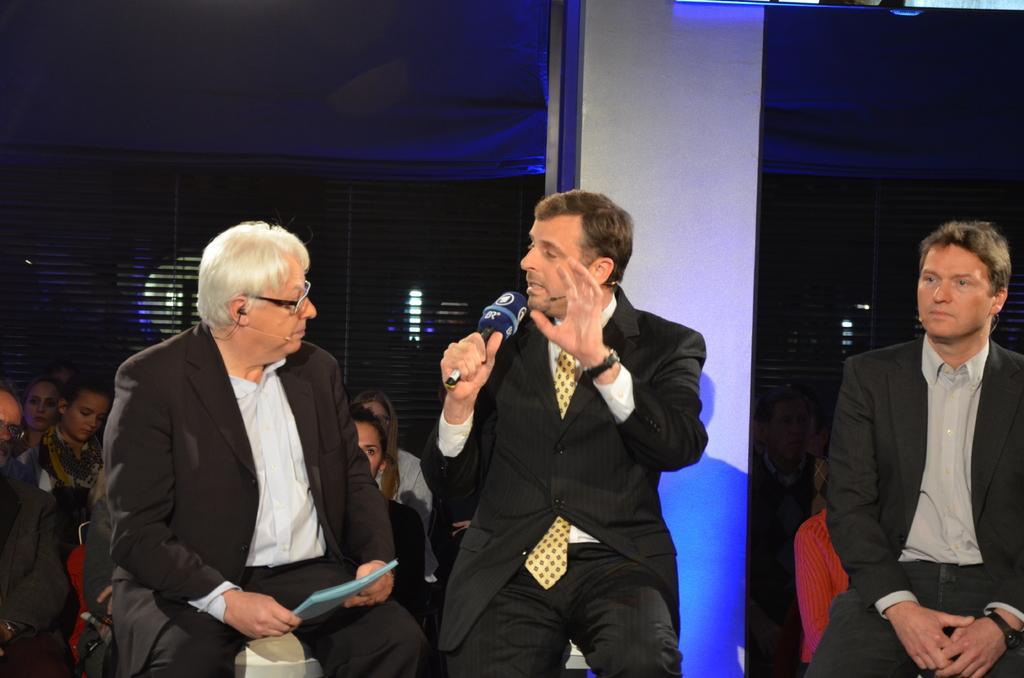In one or two sentences, can you explain what this image depicts? In this image, we can see three men in suits are sitting. In the middle of the image, a person is holding a microphone and talking. Background we can see a group of people, pillar and window shades. 